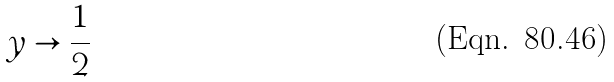Convert formula to latex. <formula><loc_0><loc_0><loc_500><loc_500>y \rightarrow \frac { 1 } { 2 }</formula> 